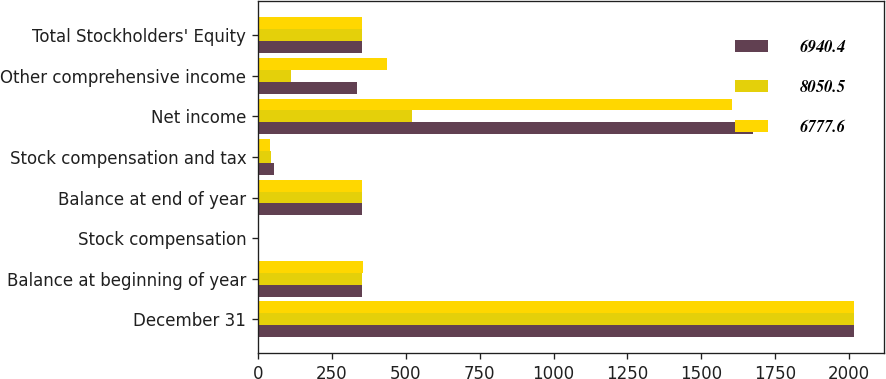Convert chart to OTSL. <chart><loc_0><loc_0><loc_500><loc_500><stacked_bar_chart><ecel><fcel>December 31<fcel>Balance at beginning of year<fcel>Stock compensation<fcel>Balance at end of year<fcel>Stock compensation and tax<fcel>Net income<fcel>Other comprehensive income<fcel>Total Stockholders' Equity<nl><fcel>6940.4<fcel>2017<fcel>350.7<fcel>1.1<fcel>351.8<fcel>53.1<fcel>1675.2<fcel>334.5<fcel>351.3<nl><fcel>8050.5<fcel>2016<fcel>351.3<fcel>0.8<fcel>350.7<fcel>44.2<fcel>521.7<fcel>111.1<fcel>351.3<nl><fcel>6777.6<fcel>2015<fcel>355.2<fcel>0.7<fcel>351.3<fcel>41.1<fcel>1604<fcel>437.2<fcel>351.3<nl></chart> 